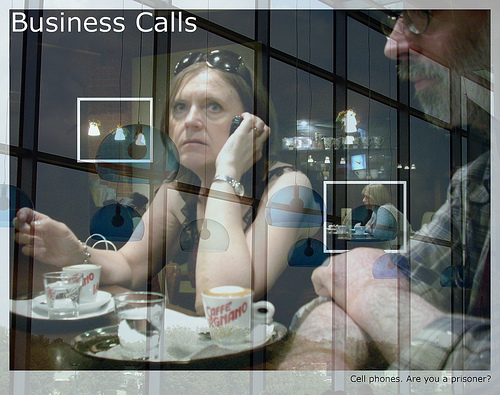Does the plate look red? No, the plate does not look red. 